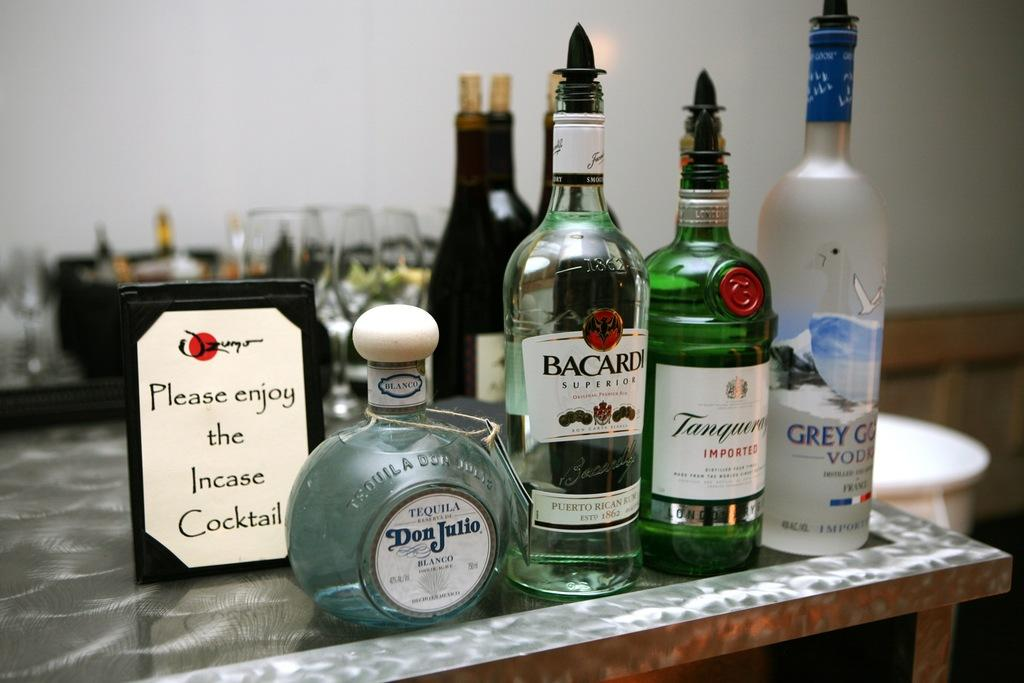<image>
Share a concise interpretation of the image provided. A group of alcohol bottles, including Bacardi and Don Julio, sitting on a table top. 